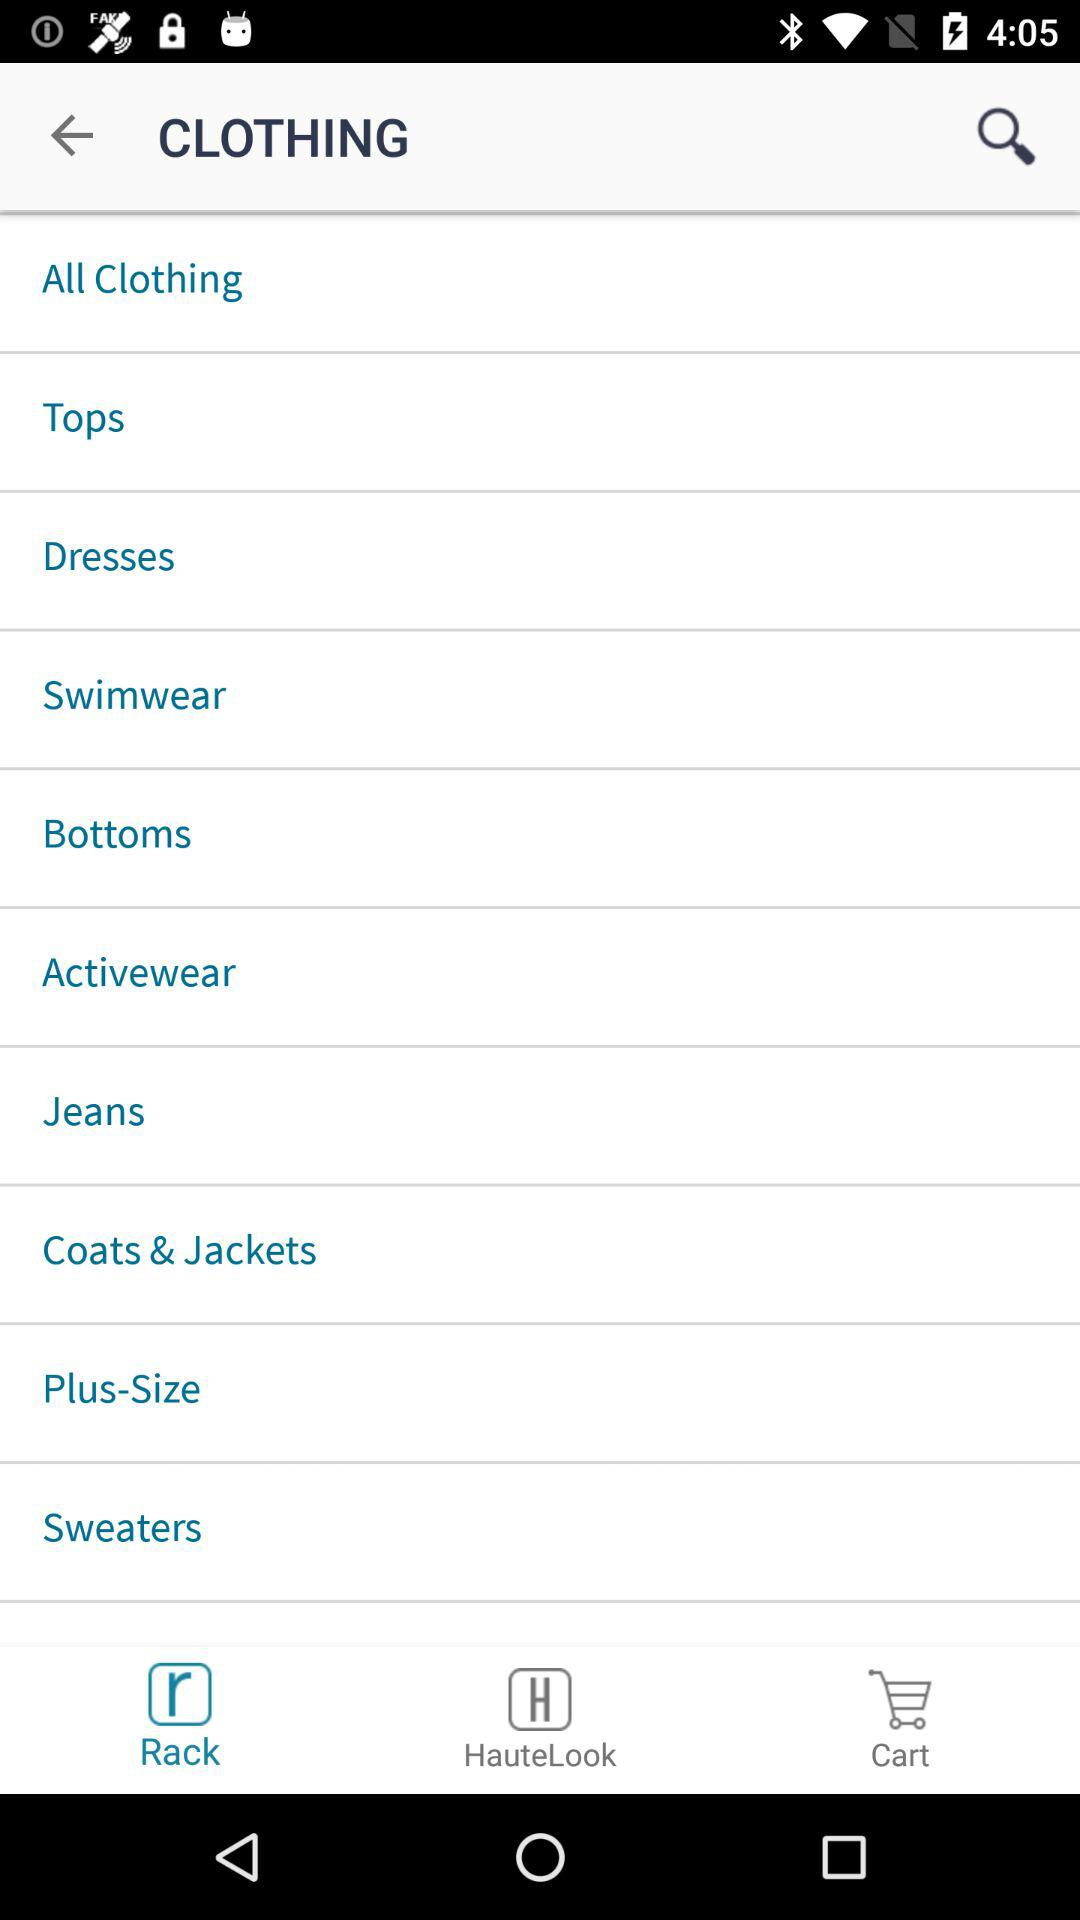What section is presently displayed? The section is "Rack". 